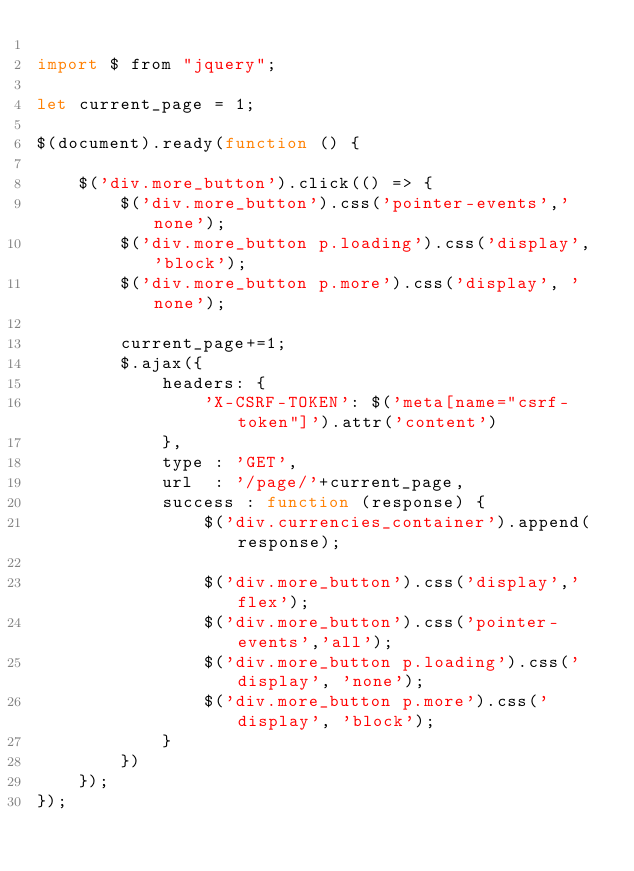Convert code to text. <code><loc_0><loc_0><loc_500><loc_500><_JavaScript_>
import $ from "jquery";

let current_page = 1;

$(document).ready(function () {

    $('div.more_button').click(() => {
        $('div.more_button').css('pointer-events','none');
        $('div.more_button p.loading').css('display', 'block');
        $('div.more_button p.more').css('display', 'none');

        current_page+=1;
        $.ajax({
            headers: {
                'X-CSRF-TOKEN': $('meta[name="csrf-token"]').attr('content')
            },
            type : 'GET',
            url  : '/page/'+current_page,
            success : function (response) {
                $('div.currencies_container').append(response);

                $('div.more_button').css('display','flex');
                $('div.more_button').css('pointer-events','all');
                $('div.more_button p.loading').css('display', 'none');
                $('div.more_button p.more').css('display', 'block');
            }
        })
    });
});
</code> 